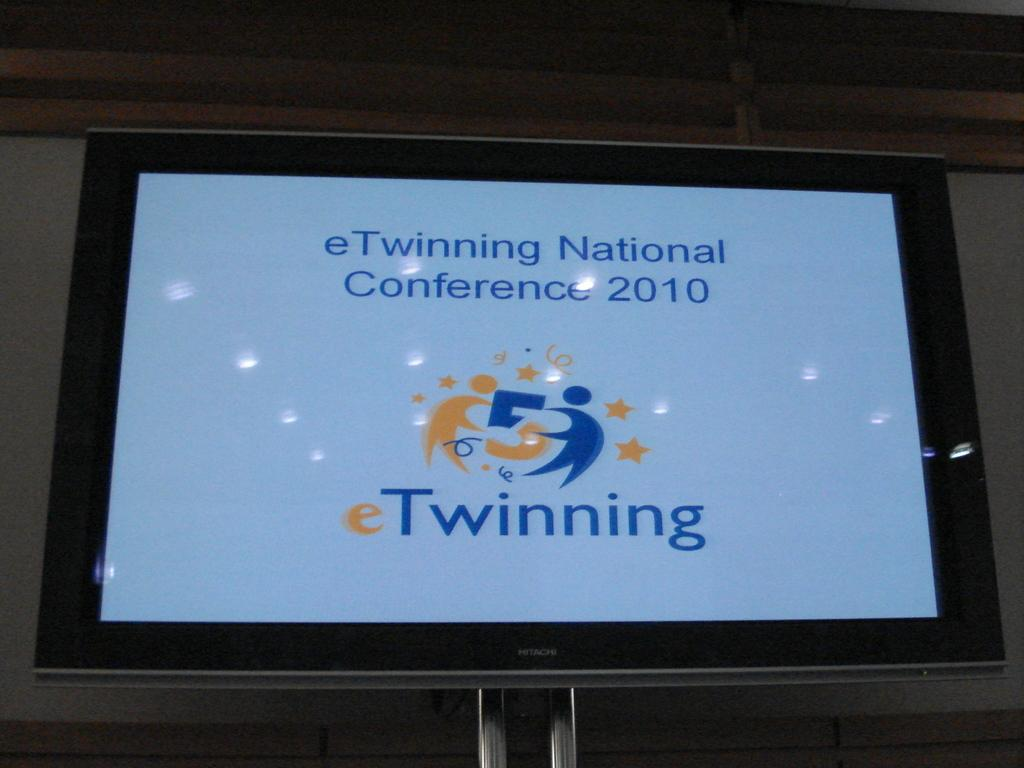<image>
Give a short and clear explanation of the subsequent image. A blue screen with the word Twinning surrounded by a black frame. 